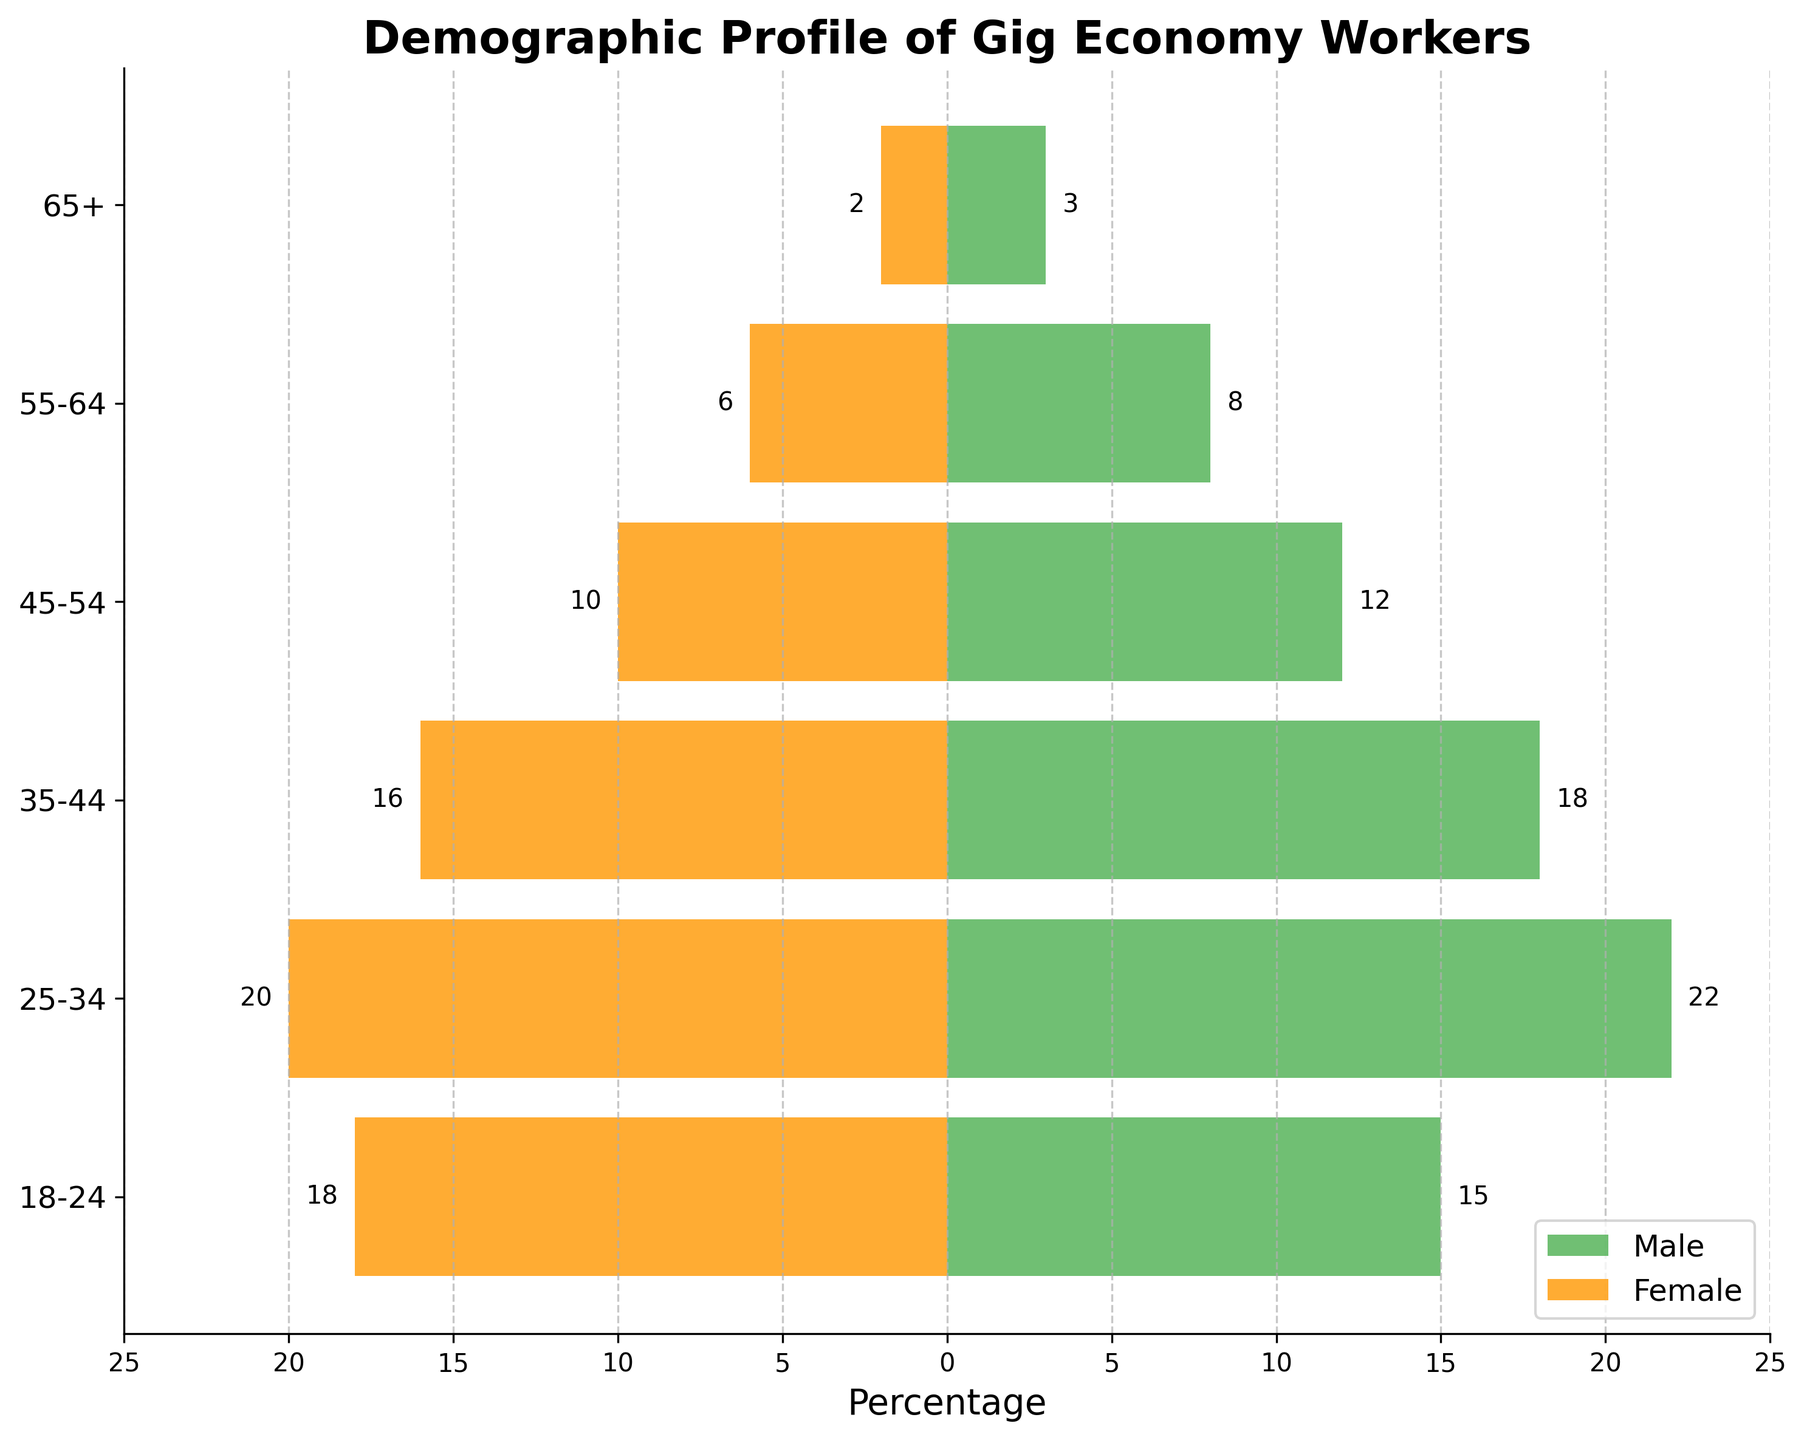What is the title of the figure? The title of the figure is displayed prominently at the top.
Answer: Demographic Profile of Gig Economy Workers What colors are used to represent males and females? The bar plot uses two distinct colors: one for males and another for females.
Answer: Green for males and orange for females What is the percentage range displayed on the x-axis? The x-axis shows the range of percentages from negative to positive values.
Answer: -25 to 25 Which age group has the highest number of male gig economy workers? By examining the length of the green bars, we can identify the age group with the longest bar for males.
Answer: 25-34 Which gender has more gig economy workers in the age group 65+? Compare the lengths of the bars for males and females in this age group.
Answer: Male 